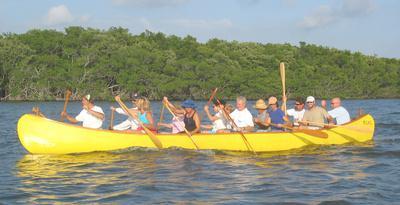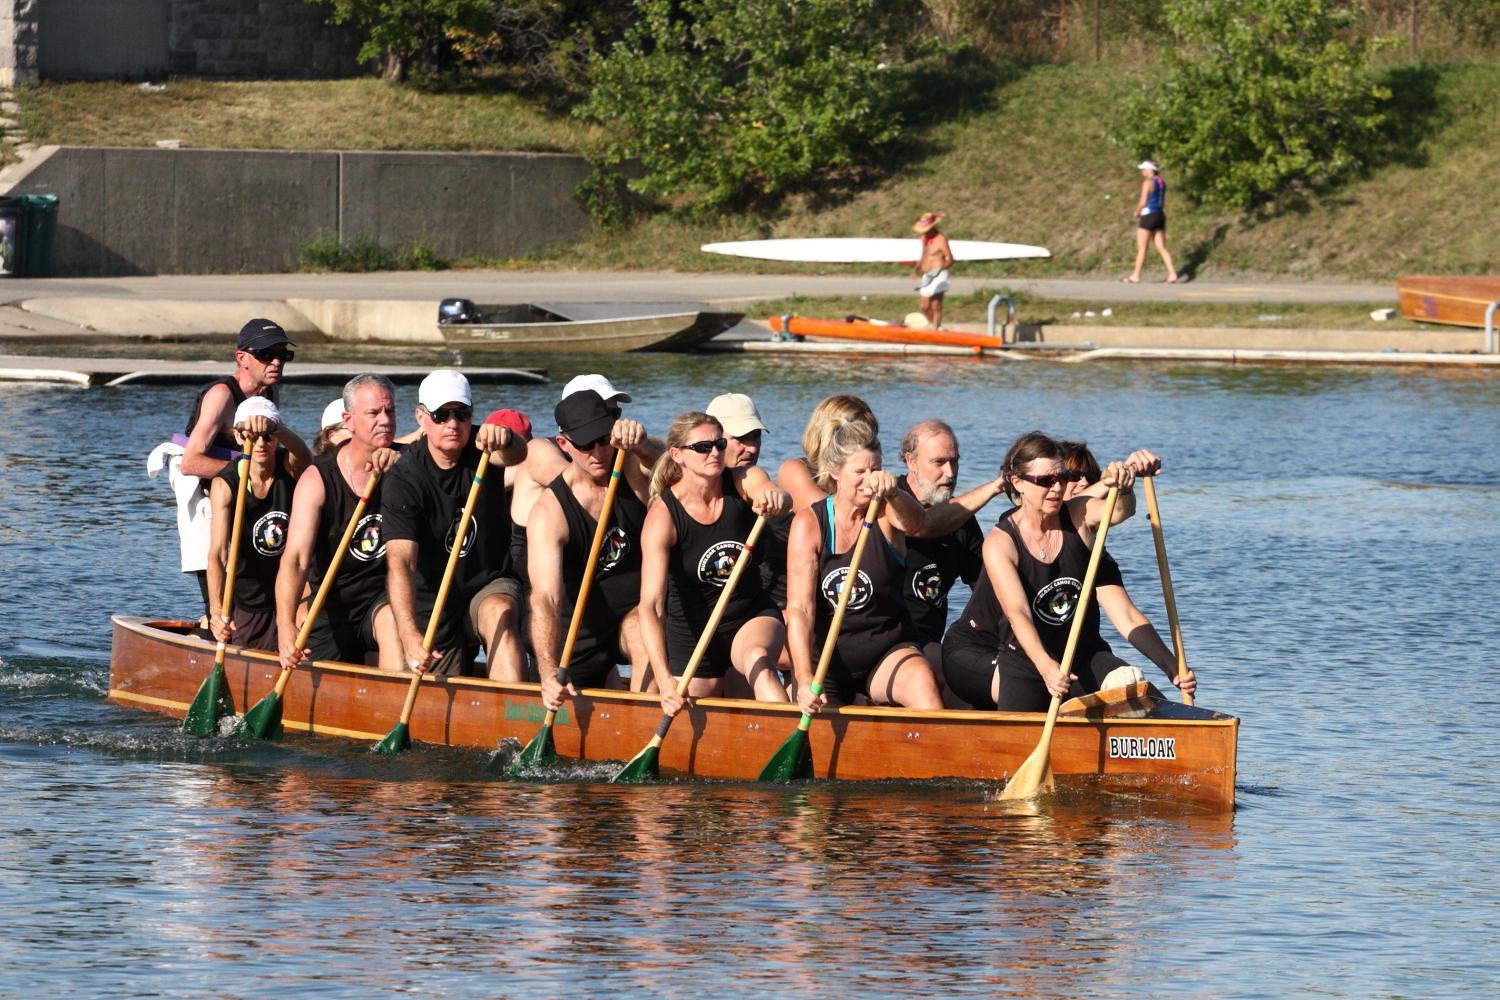The first image is the image on the left, the second image is the image on the right. Evaluate the accuracy of this statement regarding the images: "In 1 of the images, the oars are kicking up spray.". Is it true? Answer yes or no. No. The first image is the image on the left, the second image is the image on the right. Evaluate the accuracy of this statement regarding the images: "One of the boats is red.". Is it true? Answer yes or no. No. 